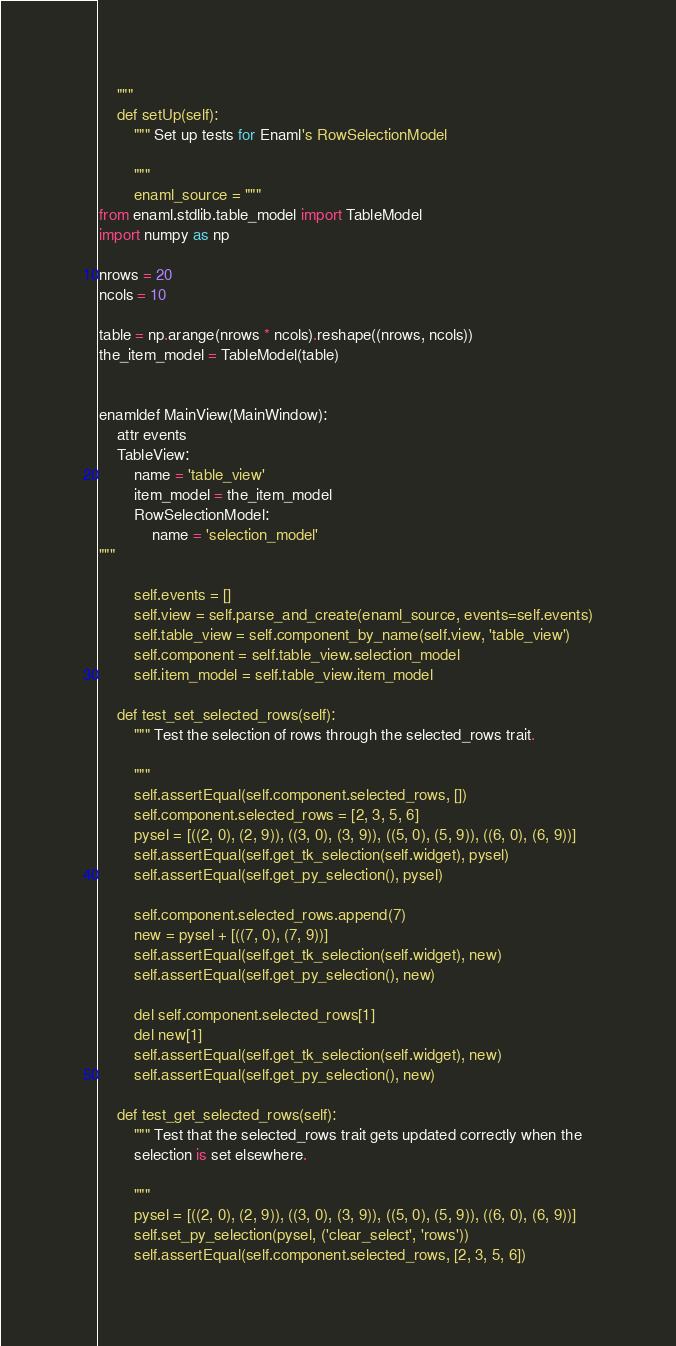Convert code to text. <code><loc_0><loc_0><loc_500><loc_500><_Python_>
    """
    def setUp(self):
        """ Set up tests for Enaml's RowSelectionModel

        """
        enaml_source = """
from enaml.stdlib.table_model import TableModel
import numpy as np

nrows = 20
ncols = 10

table = np.arange(nrows * ncols).reshape((nrows, ncols))
the_item_model = TableModel(table)


enamldef MainView(MainWindow):
    attr events
    TableView:
        name = 'table_view'
        item_model = the_item_model
        RowSelectionModel:
            name = 'selection_model'
"""

        self.events = []
        self.view = self.parse_and_create(enaml_source, events=self.events)
        self.table_view = self.component_by_name(self.view, 'table_view')
        self.component = self.table_view.selection_model
        self.item_model = self.table_view.item_model

    def test_set_selected_rows(self):
        """ Test the selection of rows through the selected_rows trait.

        """
        self.assertEqual(self.component.selected_rows, [])
        self.component.selected_rows = [2, 3, 5, 6]
        pysel = [((2, 0), (2, 9)), ((3, 0), (3, 9)), ((5, 0), (5, 9)), ((6, 0), (6, 9))]
        self.assertEqual(self.get_tk_selection(self.widget), pysel)
        self.assertEqual(self.get_py_selection(), pysel)

        self.component.selected_rows.append(7)
        new = pysel + [((7, 0), (7, 9))]
        self.assertEqual(self.get_tk_selection(self.widget), new)
        self.assertEqual(self.get_py_selection(), new)

        del self.component.selected_rows[1]
        del new[1]
        self.assertEqual(self.get_tk_selection(self.widget), new)
        self.assertEqual(self.get_py_selection(), new)

    def test_get_selected_rows(self):
        """ Test that the selected_rows trait gets updated correctly when the
        selection is set elsewhere.

        """
        pysel = [((2, 0), (2, 9)), ((3, 0), (3, 9)), ((5, 0), (5, 9)), ((6, 0), (6, 9))]
        self.set_py_selection(pysel, ('clear_select', 'rows'))
        self.assertEqual(self.component.selected_rows, [2, 3, 5, 6])

</code> 